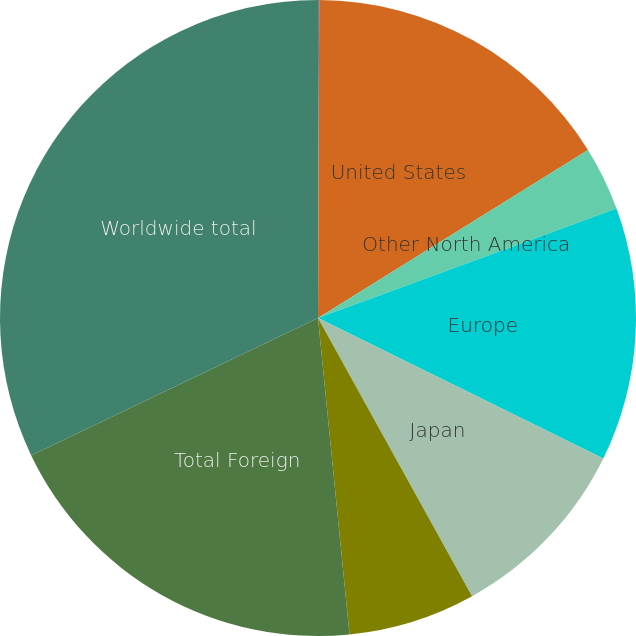<chart> <loc_0><loc_0><loc_500><loc_500><pie_chart><fcel>(In thousands)<fcel>United States<fcel>Other North America<fcel>Europe<fcel>Japan<fcel>Asia Pacific/Rest of World<fcel>Total Foreign<fcel>Worldwide total<nl><fcel>0.06%<fcel>16.08%<fcel>3.26%<fcel>12.88%<fcel>9.67%<fcel>6.47%<fcel>19.47%<fcel>32.11%<nl></chart> 